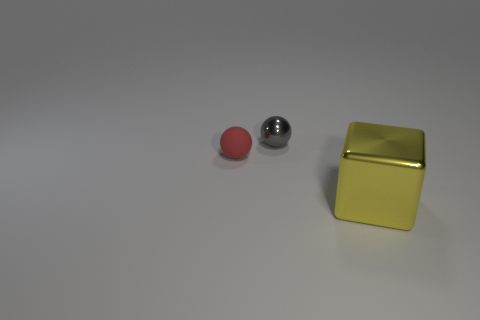Add 2 large blocks. How many objects exist? 5 Subtract all spheres. How many objects are left? 1 Add 2 tiny cubes. How many tiny cubes exist? 2 Subtract 1 gray balls. How many objects are left? 2 Subtract all large brown metallic balls. Subtract all gray metal objects. How many objects are left? 2 Add 3 gray metallic things. How many gray metallic things are left? 4 